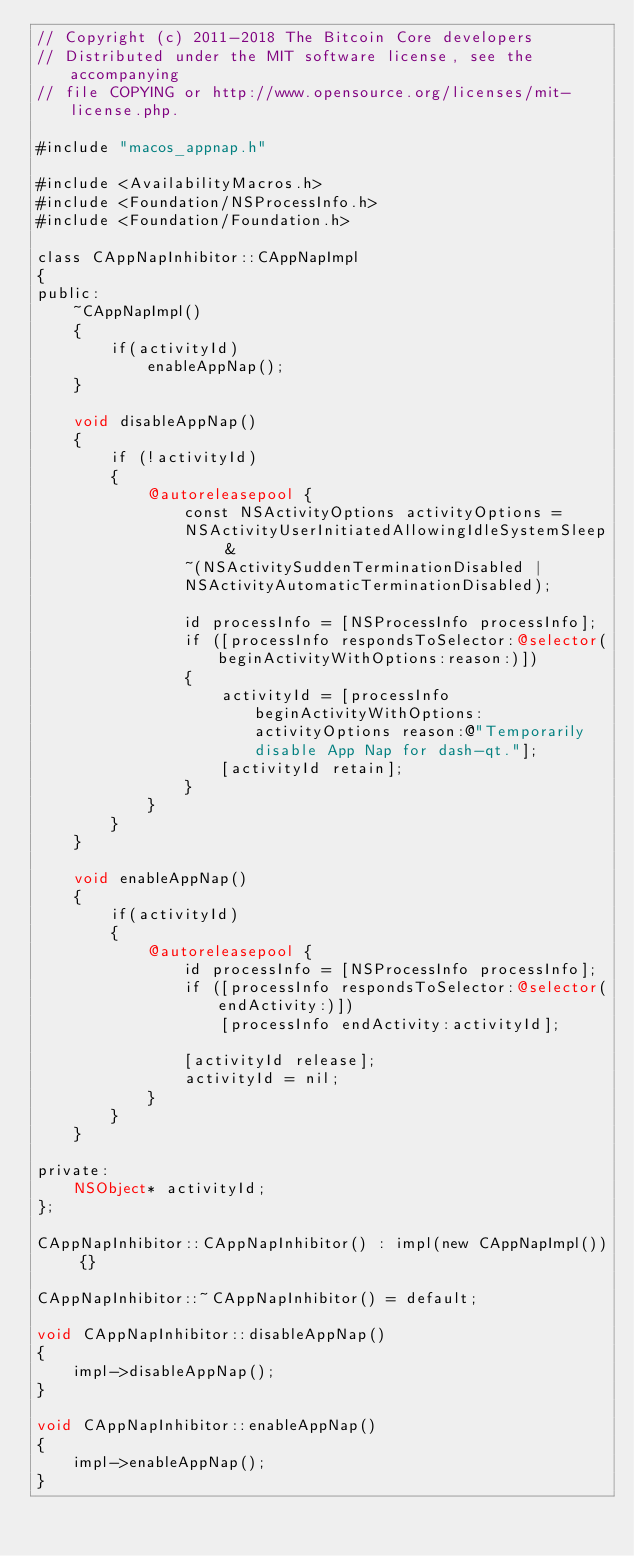<code> <loc_0><loc_0><loc_500><loc_500><_ObjectiveC_>// Copyright (c) 2011-2018 The Bitcoin Core developers
// Distributed under the MIT software license, see the accompanying
// file COPYING or http://www.opensource.org/licenses/mit-license.php.

#include "macos_appnap.h"

#include <AvailabilityMacros.h>
#include <Foundation/NSProcessInfo.h>
#include <Foundation/Foundation.h>

class CAppNapInhibitor::CAppNapImpl
{
public:
    ~CAppNapImpl()
    {
        if(activityId)
            enableAppNap();
    }

    void disableAppNap()
    {
        if (!activityId)
        {
            @autoreleasepool {
                const NSActivityOptions activityOptions =
                NSActivityUserInitiatedAllowingIdleSystemSleep &
                ~(NSActivitySuddenTerminationDisabled |
                NSActivityAutomaticTerminationDisabled);

                id processInfo = [NSProcessInfo processInfo];
                if ([processInfo respondsToSelector:@selector(beginActivityWithOptions:reason:)])
                {
                    activityId = [processInfo beginActivityWithOptions: activityOptions reason:@"Temporarily disable App Nap for dash-qt."];
                    [activityId retain];
                }
            }
        }
    }

    void enableAppNap()
    {
        if(activityId)
        {
            @autoreleasepool {
                id processInfo = [NSProcessInfo processInfo];
                if ([processInfo respondsToSelector:@selector(endActivity:)])
                    [processInfo endActivity:activityId];

                [activityId release];
                activityId = nil;
            }
        }
    }

private:
    NSObject* activityId;
};

CAppNapInhibitor::CAppNapInhibitor() : impl(new CAppNapImpl()) {}

CAppNapInhibitor::~CAppNapInhibitor() = default;

void CAppNapInhibitor::disableAppNap()
{
    impl->disableAppNap();
}

void CAppNapInhibitor::enableAppNap()
{
    impl->enableAppNap();
}
</code> 